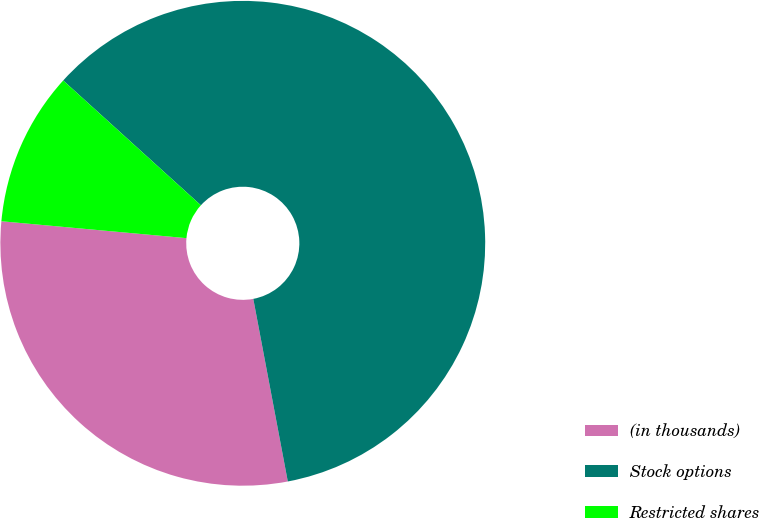Convert chart to OTSL. <chart><loc_0><loc_0><loc_500><loc_500><pie_chart><fcel>(in thousands)<fcel>Stock options<fcel>Restricted shares<nl><fcel>29.42%<fcel>60.3%<fcel>10.27%<nl></chart> 